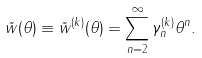Convert formula to latex. <formula><loc_0><loc_0><loc_500><loc_500>\tilde { w } ( \theta ) \equiv \tilde { w } ^ { ( k ) } ( \theta ) = \sum _ { n = 2 } ^ { \infty } \gamma _ { n } ^ { ( k ) } \theta ^ { n } .</formula> 